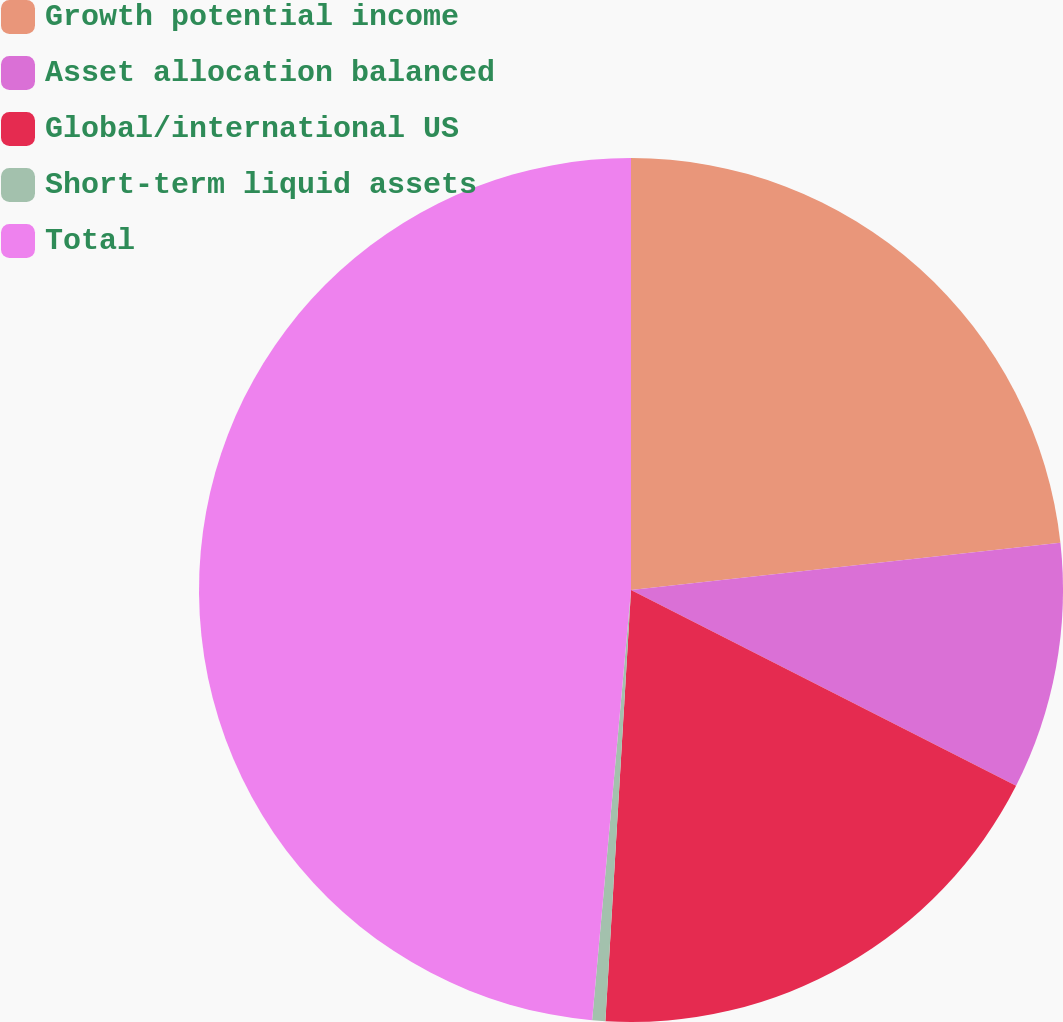Convert chart to OTSL. <chart><loc_0><loc_0><loc_500><loc_500><pie_chart><fcel>Growth potential income<fcel>Asset allocation balanced<fcel>Global/international US<fcel>Short-term liquid assets<fcel>Total<nl><fcel>23.26%<fcel>9.23%<fcel>18.46%<fcel>0.49%<fcel>48.57%<nl></chart> 